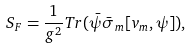<formula> <loc_0><loc_0><loc_500><loc_500>S _ { F } = \frac { 1 } { g ^ { 2 } } T r ( \bar { \psi } \bar { \sigma } _ { m } [ v _ { m } , \psi ] ) ,</formula> 